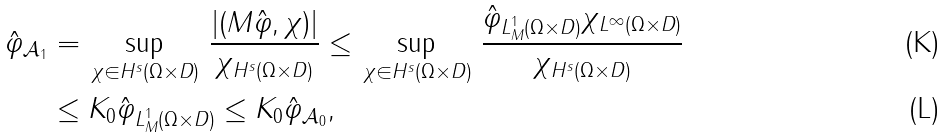Convert formula to latex. <formula><loc_0><loc_0><loc_500><loc_500>\| \hat { \varphi } \| _ { \mathcal { A } _ { 1 } } & = \sup _ { \, \chi \in H ^ { s } ( \Omega \times D ) } \, \frac { | ( M \hat { \varphi } , \chi ) | } { \| \chi \| _ { H ^ { s } ( \Omega \times D ) } } \leq \sup _ { \, \chi \in H ^ { s } ( \Omega \times D ) } \, \frac { \| \hat { \varphi } \| _ { L ^ { 1 } _ { M } ( \Omega \times D ) } \| \chi \| _ { L ^ { \infty } ( \Omega \times D ) } } { \| \chi \| _ { H ^ { s } ( \Omega \times D ) } } \\ & \leq K _ { 0 } \| \hat { \varphi } \| _ { L ^ { 1 } _ { M } ( \Omega \times D ) } \leq K _ { 0 } \| \hat { \varphi } \| _ { \mathcal { A } _ { 0 } } ,</formula> 